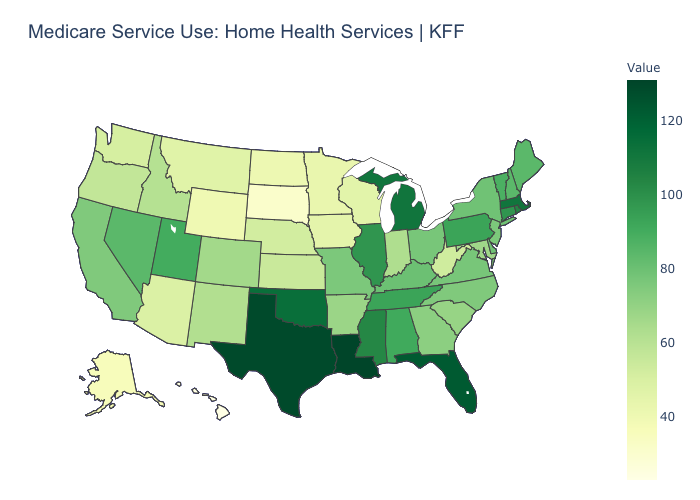Does Louisiana have the highest value in the USA?
Quick response, please. Yes. Which states have the lowest value in the South?
Give a very brief answer. West Virginia. Does Missouri have the lowest value in the USA?
Concise answer only. No. Which states have the highest value in the USA?
Answer briefly. Louisiana. Which states have the lowest value in the USA?
Be succinct. Hawaii. Which states have the lowest value in the Northeast?
Short answer required. New Jersey. Among the states that border Nebraska , does South Dakota have the highest value?
Give a very brief answer. No. 